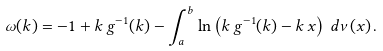<formula> <loc_0><loc_0><loc_500><loc_500>\omega ( k ) = - 1 + k \, g ^ { - 1 } ( k ) - \int _ { a } ^ { b } \ln \left ( k \, g ^ { - 1 } ( k ) - k \, x \right ) \, d \nu ( x ) \, .</formula> 